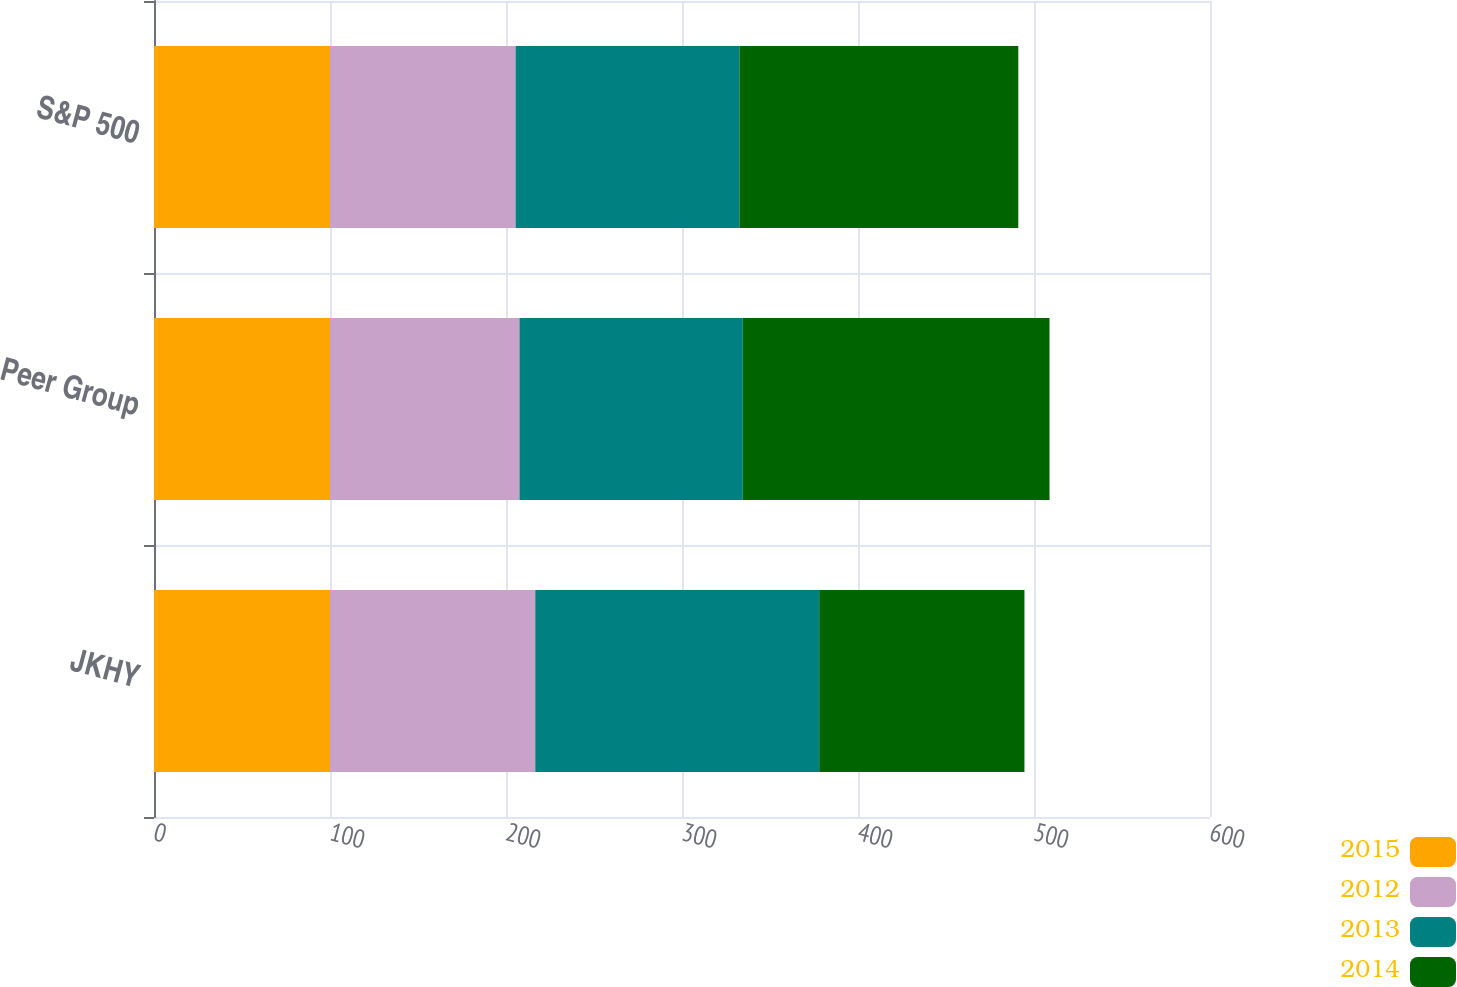Convert chart. <chart><loc_0><loc_0><loc_500><loc_500><stacked_bar_chart><ecel><fcel>JKHY<fcel>Peer Group<fcel>S&P 500<nl><fcel>2015<fcel>100<fcel>100<fcel>100<nl><fcel>2012<fcel>116.62<fcel>107.65<fcel>105.45<nl><fcel>2013<fcel>161.33<fcel>126.89<fcel>127.17<nl><fcel>2014<fcel>116.62<fcel>174.28<fcel>158.46<nl></chart> 